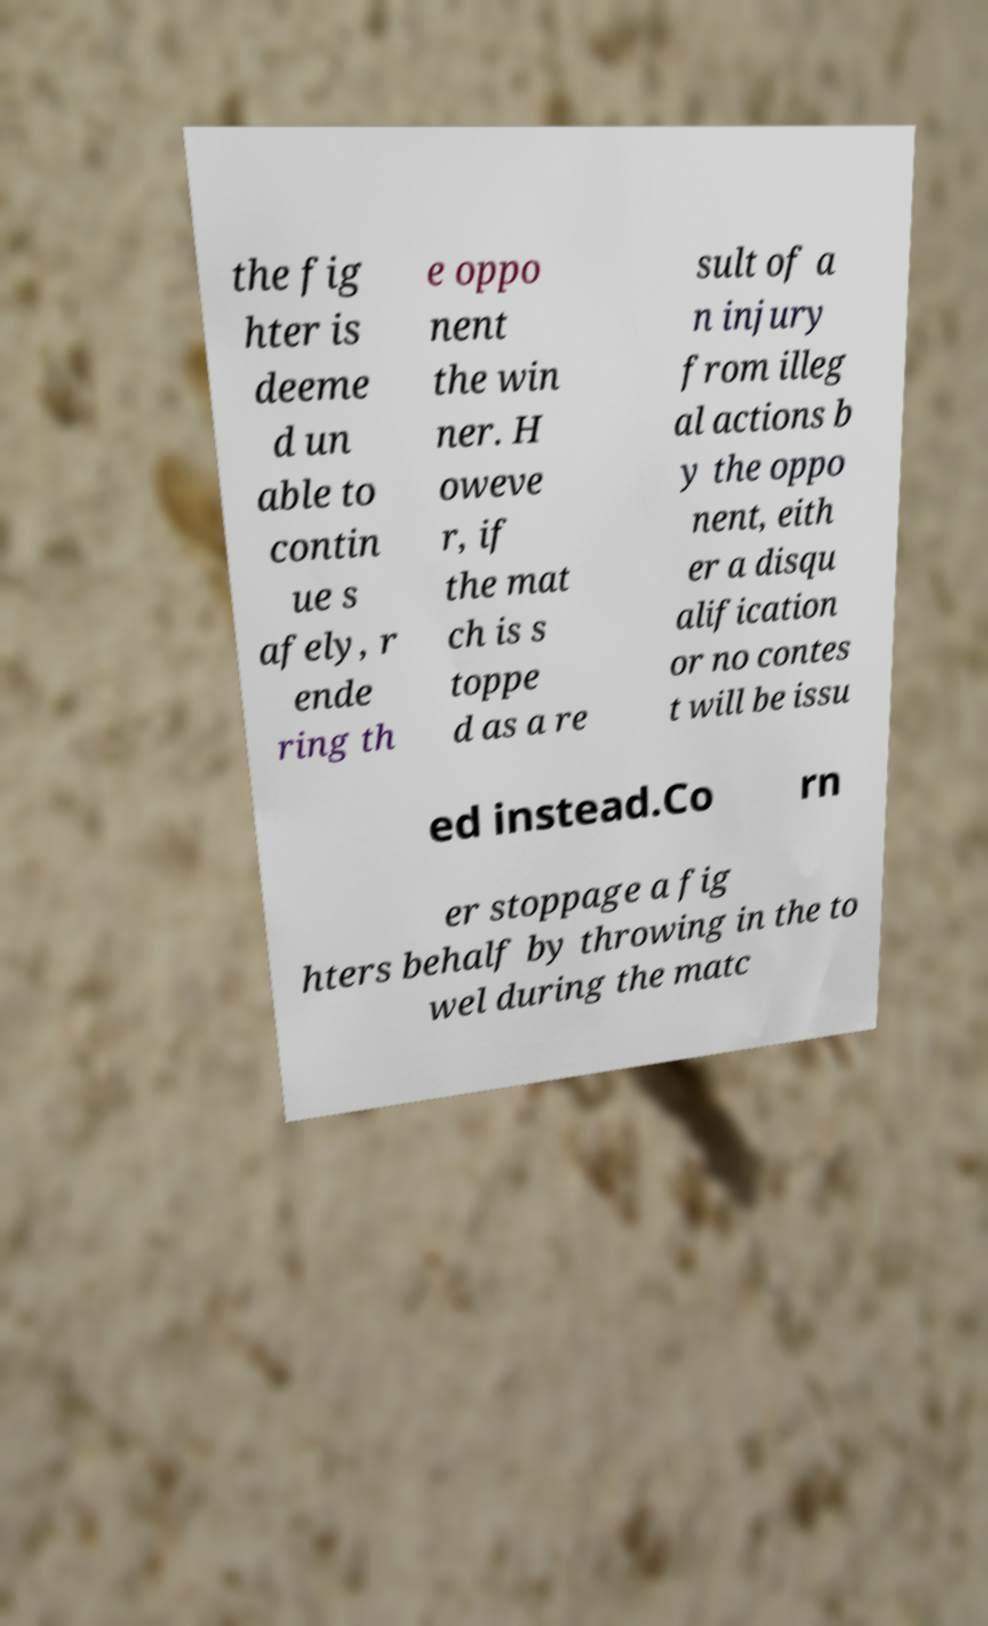Can you read and provide the text displayed in the image?This photo seems to have some interesting text. Can you extract and type it out for me? the fig hter is deeme d un able to contin ue s afely, r ende ring th e oppo nent the win ner. H oweve r, if the mat ch is s toppe d as a re sult of a n injury from illeg al actions b y the oppo nent, eith er a disqu alification or no contes t will be issu ed instead.Co rn er stoppage a fig hters behalf by throwing in the to wel during the matc 